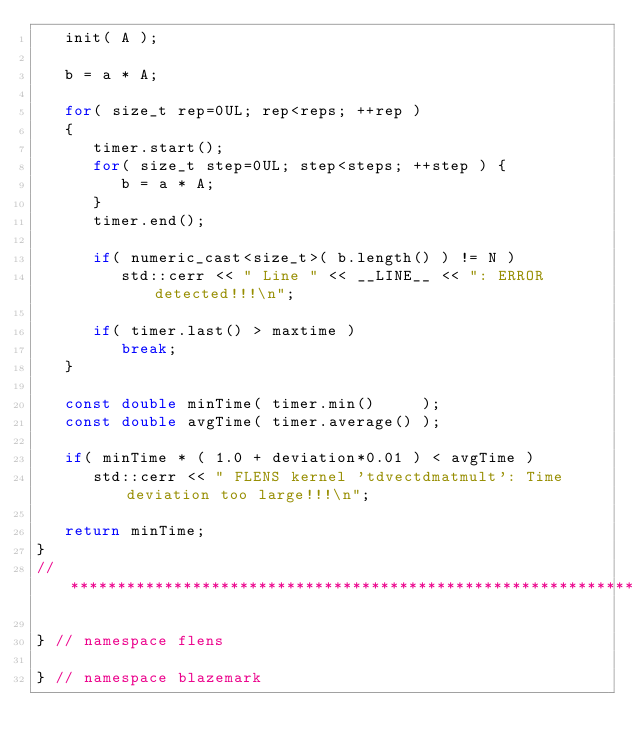<code> <loc_0><loc_0><loc_500><loc_500><_C++_>   init( A );

   b = a * A;

   for( size_t rep=0UL; rep<reps; ++rep )
   {
      timer.start();
      for( size_t step=0UL; step<steps; ++step ) {
         b = a * A;
      }
      timer.end();

      if( numeric_cast<size_t>( b.length() ) != N )
         std::cerr << " Line " << __LINE__ << ": ERROR detected!!!\n";

      if( timer.last() > maxtime )
         break;
   }

   const double minTime( timer.min()     );
   const double avgTime( timer.average() );

   if( minTime * ( 1.0 + deviation*0.01 ) < avgTime )
      std::cerr << " FLENS kernel 'tdvectdmatmult': Time deviation too large!!!\n";

   return minTime;
}
//*************************************************************************************************

} // namespace flens

} // namespace blazemark
</code> 